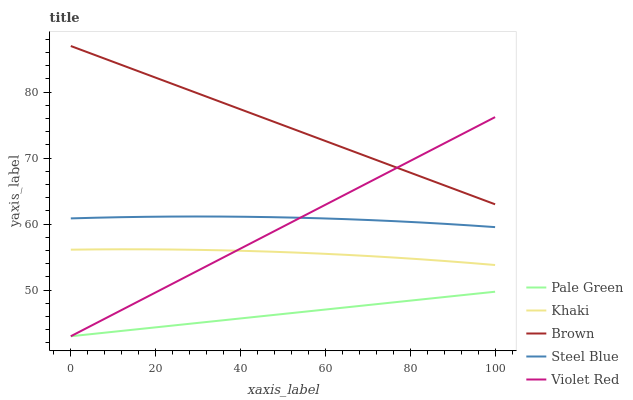Does Pale Green have the minimum area under the curve?
Answer yes or no. Yes. Does Brown have the maximum area under the curve?
Answer yes or no. Yes. Does Violet Red have the minimum area under the curve?
Answer yes or no. No. Does Violet Red have the maximum area under the curve?
Answer yes or no. No. Is Pale Green the smoothest?
Answer yes or no. Yes. Is Steel Blue the roughest?
Answer yes or no. Yes. Is Violet Red the smoothest?
Answer yes or no. No. Is Violet Red the roughest?
Answer yes or no. No. Does Violet Red have the lowest value?
Answer yes or no. Yes. Does Khaki have the lowest value?
Answer yes or no. No. Does Brown have the highest value?
Answer yes or no. Yes. Does Violet Red have the highest value?
Answer yes or no. No. Is Steel Blue less than Brown?
Answer yes or no. Yes. Is Steel Blue greater than Khaki?
Answer yes or no. Yes. Does Violet Red intersect Brown?
Answer yes or no. Yes. Is Violet Red less than Brown?
Answer yes or no. No. Is Violet Red greater than Brown?
Answer yes or no. No. Does Steel Blue intersect Brown?
Answer yes or no. No. 